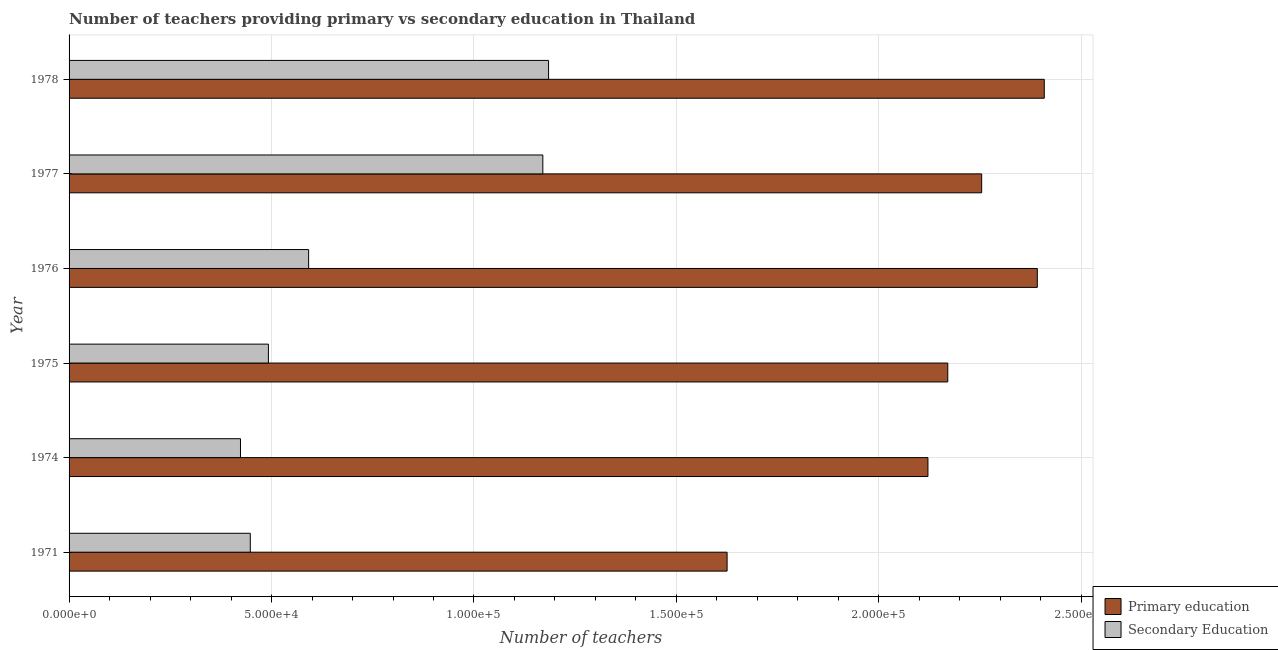Are the number of bars per tick equal to the number of legend labels?
Make the answer very short. Yes. Are the number of bars on each tick of the Y-axis equal?
Make the answer very short. Yes. How many bars are there on the 6th tick from the top?
Your answer should be very brief. 2. How many bars are there on the 5th tick from the bottom?
Offer a terse response. 2. In how many cases, is the number of bars for a given year not equal to the number of legend labels?
Provide a short and direct response. 0. What is the number of secondary teachers in 1978?
Provide a succinct answer. 1.18e+05. Across all years, what is the maximum number of primary teachers?
Keep it short and to the point. 2.41e+05. Across all years, what is the minimum number of secondary teachers?
Ensure brevity in your answer.  4.23e+04. In which year was the number of primary teachers maximum?
Ensure brevity in your answer.  1978. What is the total number of primary teachers in the graph?
Your answer should be compact. 1.30e+06. What is the difference between the number of primary teachers in 1974 and that in 1976?
Your answer should be very brief. -2.70e+04. What is the difference between the number of primary teachers in 1978 and the number of secondary teachers in 1977?
Your answer should be very brief. 1.24e+05. What is the average number of secondary teachers per year?
Offer a very short reply. 7.18e+04. In the year 1976, what is the difference between the number of primary teachers and number of secondary teachers?
Your answer should be very brief. 1.80e+05. What is the ratio of the number of secondary teachers in 1971 to that in 1976?
Provide a succinct answer. 0.76. Is the difference between the number of secondary teachers in 1974 and 1978 greater than the difference between the number of primary teachers in 1974 and 1978?
Your response must be concise. No. What is the difference between the highest and the second highest number of primary teachers?
Offer a very short reply. 1716. What is the difference between the highest and the lowest number of primary teachers?
Your answer should be compact. 7.83e+04. Is the sum of the number of secondary teachers in 1974 and 1977 greater than the maximum number of primary teachers across all years?
Make the answer very short. No. What does the 1st bar from the top in 1974 represents?
Provide a succinct answer. Secondary Education. What does the 2nd bar from the bottom in 1971 represents?
Make the answer very short. Secondary Education. Are all the bars in the graph horizontal?
Provide a short and direct response. Yes. How many years are there in the graph?
Give a very brief answer. 6. What is the difference between two consecutive major ticks on the X-axis?
Provide a succinct answer. 5.00e+04. Are the values on the major ticks of X-axis written in scientific E-notation?
Your response must be concise. Yes. Where does the legend appear in the graph?
Your answer should be compact. Bottom right. How many legend labels are there?
Your answer should be very brief. 2. What is the title of the graph?
Your answer should be very brief. Number of teachers providing primary vs secondary education in Thailand. Does "Methane emissions" appear as one of the legend labels in the graph?
Give a very brief answer. No. What is the label or title of the X-axis?
Give a very brief answer. Number of teachers. What is the label or title of the Y-axis?
Ensure brevity in your answer.  Year. What is the Number of teachers of Primary education in 1971?
Provide a short and direct response. 1.63e+05. What is the Number of teachers in Secondary Education in 1971?
Offer a terse response. 4.48e+04. What is the Number of teachers in Primary education in 1974?
Your answer should be compact. 2.12e+05. What is the Number of teachers of Secondary Education in 1974?
Provide a short and direct response. 4.23e+04. What is the Number of teachers of Primary education in 1975?
Provide a short and direct response. 2.17e+05. What is the Number of teachers of Secondary Education in 1975?
Give a very brief answer. 4.92e+04. What is the Number of teachers in Primary education in 1976?
Provide a succinct answer. 2.39e+05. What is the Number of teachers of Secondary Education in 1976?
Your answer should be very brief. 5.92e+04. What is the Number of teachers in Primary education in 1977?
Your answer should be very brief. 2.25e+05. What is the Number of teachers in Secondary Education in 1977?
Your answer should be very brief. 1.17e+05. What is the Number of teachers in Primary education in 1978?
Offer a terse response. 2.41e+05. What is the Number of teachers in Secondary Education in 1978?
Offer a very short reply. 1.18e+05. Across all years, what is the maximum Number of teachers in Primary education?
Provide a short and direct response. 2.41e+05. Across all years, what is the maximum Number of teachers of Secondary Education?
Give a very brief answer. 1.18e+05. Across all years, what is the minimum Number of teachers of Primary education?
Provide a short and direct response. 1.63e+05. Across all years, what is the minimum Number of teachers of Secondary Education?
Offer a very short reply. 4.23e+04. What is the total Number of teachers of Primary education in the graph?
Provide a short and direct response. 1.30e+06. What is the total Number of teachers in Secondary Education in the graph?
Keep it short and to the point. 4.31e+05. What is the difference between the Number of teachers of Primary education in 1971 and that in 1974?
Your response must be concise. -4.96e+04. What is the difference between the Number of teachers in Secondary Education in 1971 and that in 1974?
Your answer should be very brief. 2420. What is the difference between the Number of teachers of Primary education in 1971 and that in 1975?
Provide a short and direct response. -5.45e+04. What is the difference between the Number of teachers in Secondary Education in 1971 and that in 1975?
Keep it short and to the point. -4473. What is the difference between the Number of teachers of Primary education in 1971 and that in 1976?
Ensure brevity in your answer.  -7.66e+04. What is the difference between the Number of teachers of Secondary Education in 1971 and that in 1976?
Ensure brevity in your answer.  -1.44e+04. What is the difference between the Number of teachers in Primary education in 1971 and that in 1977?
Make the answer very short. -6.29e+04. What is the difference between the Number of teachers of Secondary Education in 1971 and that in 1977?
Offer a terse response. -7.22e+04. What is the difference between the Number of teachers in Primary education in 1971 and that in 1978?
Offer a very short reply. -7.83e+04. What is the difference between the Number of teachers in Secondary Education in 1971 and that in 1978?
Offer a terse response. -7.37e+04. What is the difference between the Number of teachers of Primary education in 1974 and that in 1975?
Your answer should be compact. -4901. What is the difference between the Number of teachers of Secondary Education in 1974 and that in 1975?
Give a very brief answer. -6893. What is the difference between the Number of teachers of Primary education in 1974 and that in 1976?
Provide a succinct answer. -2.70e+04. What is the difference between the Number of teachers in Secondary Education in 1974 and that in 1976?
Your answer should be compact. -1.68e+04. What is the difference between the Number of teachers of Primary education in 1974 and that in 1977?
Give a very brief answer. -1.33e+04. What is the difference between the Number of teachers in Secondary Education in 1974 and that in 1977?
Your answer should be compact. -7.47e+04. What is the difference between the Number of teachers of Primary education in 1974 and that in 1978?
Offer a terse response. -2.87e+04. What is the difference between the Number of teachers in Secondary Education in 1974 and that in 1978?
Your answer should be very brief. -7.61e+04. What is the difference between the Number of teachers of Primary education in 1975 and that in 1976?
Your response must be concise. -2.21e+04. What is the difference between the Number of teachers of Secondary Education in 1975 and that in 1976?
Give a very brief answer. -9932. What is the difference between the Number of teachers in Primary education in 1975 and that in 1977?
Make the answer very short. -8372. What is the difference between the Number of teachers of Secondary Education in 1975 and that in 1977?
Ensure brevity in your answer.  -6.78e+04. What is the difference between the Number of teachers of Primary education in 1975 and that in 1978?
Make the answer very short. -2.38e+04. What is the difference between the Number of teachers in Secondary Education in 1975 and that in 1978?
Give a very brief answer. -6.92e+04. What is the difference between the Number of teachers in Primary education in 1976 and that in 1977?
Make the answer very short. 1.37e+04. What is the difference between the Number of teachers in Secondary Education in 1976 and that in 1977?
Your response must be concise. -5.78e+04. What is the difference between the Number of teachers in Primary education in 1976 and that in 1978?
Your answer should be very brief. -1716. What is the difference between the Number of teachers of Secondary Education in 1976 and that in 1978?
Your answer should be compact. -5.93e+04. What is the difference between the Number of teachers of Primary education in 1977 and that in 1978?
Your response must be concise. -1.55e+04. What is the difference between the Number of teachers of Secondary Education in 1977 and that in 1978?
Keep it short and to the point. -1418. What is the difference between the Number of teachers of Primary education in 1971 and the Number of teachers of Secondary Education in 1974?
Ensure brevity in your answer.  1.20e+05. What is the difference between the Number of teachers in Primary education in 1971 and the Number of teachers in Secondary Education in 1975?
Offer a terse response. 1.13e+05. What is the difference between the Number of teachers of Primary education in 1971 and the Number of teachers of Secondary Education in 1976?
Provide a succinct answer. 1.03e+05. What is the difference between the Number of teachers of Primary education in 1971 and the Number of teachers of Secondary Education in 1977?
Your answer should be compact. 4.55e+04. What is the difference between the Number of teachers of Primary education in 1971 and the Number of teachers of Secondary Education in 1978?
Offer a terse response. 4.41e+04. What is the difference between the Number of teachers of Primary education in 1974 and the Number of teachers of Secondary Education in 1975?
Make the answer very short. 1.63e+05. What is the difference between the Number of teachers of Primary education in 1974 and the Number of teachers of Secondary Education in 1976?
Provide a succinct answer. 1.53e+05. What is the difference between the Number of teachers in Primary education in 1974 and the Number of teachers in Secondary Education in 1977?
Provide a short and direct response. 9.51e+04. What is the difference between the Number of teachers in Primary education in 1974 and the Number of teachers in Secondary Education in 1978?
Keep it short and to the point. 9.37e+04. What is the difference between the Number of teachers in Primary education in 1975 and the Number of teachers in Secondary Education in 1976?
Offer a very short reply. 1.58e+05. What is the difference between the Number of teachers of Primary education in 1975 and the Number of teachers of Secondary Education in 1977?
Offer a very short reply. 1.00e+05. What is the difference between the Number of teachers in Primary education in 1975 and the Number of teachers in Secondary Education in 1978?
Ensure brevity in your answer.  9.86e+04. What is the difference between the Number of teachers in Primary education in 1976 and the Number of teachers in Secondary Education in 1977?
Provide a short and direct response. 1.22e+05. What is the difference between the Number of teachers in Primary education in 1976 and the Number of teachers in Secondary Education in 1978?
Provide a succinct answer. 1.21e+05. What is the difference between the Number of teachers of Primary education in 1977 and the Number of teachers of Secondary Education in 1978?
Offer a very short reply. 1.07e+05. What is the average Number of teachers of Primary education per year?
Keep it short and to the point. 2.16e+05. What is the average Number of teachers in Secondary Education per year?
Ensure brevity in your answer.  7.18e+04. In the year 1971, what is the difference between the Number of teachers of Primary education and Number of teachers of Secondary Education?
Provide a short and direct response. 1.18e+05. In the year 1974, what is the difference between the Number of teachers in Primary education and Number of teachers in Secondary Education?
Your answer should be very brief. 1.70e+05. In the year 1975, what is the difference between the Number of teachers in Primary education and Number of teachers in Secondary Education?
Give a very brief answer. 1.68e+05. In the year 1976, what is the difference between the Number of teachers in Primary education and Number of teachers in Secondary Education?
Provide a succinct answer. 1.80e+05. In the year 1977, what is the difference between the Number of teachers of Primary education and Number of teachers of Secondary Education?
Provide a succinct answer. 1.08e+05. In the year 1978, what is the difference between the Number of teachers of Primary education and Number of teachers of Secondary Education?
Make the answer very short. 1.22e+05. What is the ratio of the Number of teachers of Primary education in 1971 to that in 1974?
Keep it short and to the point. 0.77. What is the ratio of the Number of teachers of Secondary Education in 1971 to that in 1974?
Offer a very short reply. 1.06. What is the ratio of the Number of teachers of Primary education in 1971 to that in 1975?
Your answer should be compact. 0.75. What is the ratio of the Number of teachers in Secondary Education in 1971 to that in 1975?
Your answer should be compact. 0.91. What is the ratio of the Number of teachers of Primary education in 1971 to that in 1976?
Provide a short and direct response. 0.68. What is the ratio of the Number of teachers in Secondary Education in 1971 to that in 1976?
Give a very brief answer. 0.76. What is the ratio of the Number of teachers in Primary education in 1971 to that in 1977?
Provide a short and direct response. 0.72. What is the ratio of the Number of teachers of Secondary Education in 1971 to that in 1977?
Your response must be concise. 0.38. What is the ratio of the Number of teachers in Primary education in 1971 to that in 1978?
Your answer should be compact. 0.67. What is the ratio of the Number of teachers in Secondary Education in 1971 to that in 1978?
Offer a very short reply. 0.38. What is the ratio of the Number of teachers of Primary education in 1974 to that in 1975?
Ensure brevity in your answer.  0.98. What is the ratio of the Number of teachers in Secondary Education in 1974 to that in 1975?
Provide a short and direct response. 0.86. What is the ratio of the Number of teachers of Primary education in 1974 to that in 1976?
Keep it short and to the point. 0.89. What is the ratio of the Number of teachers of Secondary Education in 1974 to that in 1976?
Keep it short and to the point. 0.72. What is the ratio of the Number of teachers of Primary education in 1974 to that in 1977?
Make the answer very short. 0.94. What is the ratio of the Number of teachers in Secondary Education in 1974 to that in 1977?
Your answer should be compact. 0.36. What is the ratio of the Number of teachers in Primary education in 1974 to that in 1978?
Provide a succinct answer. 0.88. What is the ratio of the Number of teachers of Secondary Education in 1974 to that in 1978?
Offer a very short reply. 0.36. What is the ratio of the Number of teachers in Primary education in 1975 to that in 1976?
Provide a succinct answer. 0.91. What is the ratio of the Number of teachers of Secondary Education in 1975 to that in 1976?
Provide a succinct answer. 0.83. What is the ratio of the Number of teachers of Primary education in 1975 to that in 1977?
Make the answer very short. 0.96. What is the ratio of the Number of teachers of Secondary Education in 1975 to that in 1977?
Ensure brevity in your answer.  0.42. What is the ratio of the Number of teachers of Primary education in 1975 to that in 1978?
Your answer should be very brief. 0.9. What is the ratio of the Number of teachers of Secondary Education in 1975 to that in 1978?
Offer a terse response. 0.42. What is the ratio of the Number of teachers of Primary education in 1976 to that in 1977?
Ensure brevity in your answer.  1.06. What is the ratio of the Number of teachers of Secondary Education in 1976 to that in 1977?
Provide a succinct answer. 0.51. What is the ratio of the Number of teachers in Primary education in 1976 to that in 1978?
Your answer should be very brief. 0.99. What is the ratio of the Number of teachers in Secondary Education in 1976 to that in 1978?
Give a very brief answer. 0.5. What is the ratio of the Number of teachers in Primary education in 1977 to that in 1978?
Give a very brief answer. 0.94. What is the difference between the highest and the second highest Number of teachers in Primary education?
Your answer should be compact. 1716. What is the difference between the highest and the second highest Number of teachers in Secondary Education?
Give a very brief answer. 1418. What is the difference between the highest and the lowest Number of teachers of Primary education?
Offer a terse response. 7.83e+04. What is the difference between the highest and the lowest Number of teachers in Secondary Education?
Provide a succinct answer. 7.61e+04. 